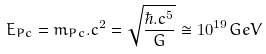<formula> <loc_0><loc_0><loc_500><loc_500>E _ { P c } = m _ { P c } . c ^ { 2 } = \sqrt { \frac { { \hbar { . } c ^ { 5 } } } { G } } \cong 1 0 ^ { 1 9 } G e V</formula> 